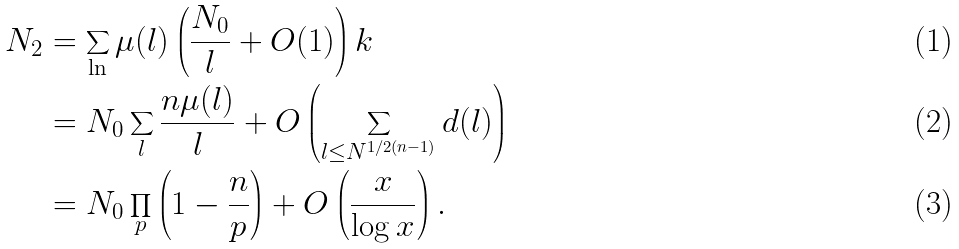<formula> <loc_0><loc_0><loc_500><loc_500>N _ { 2 } & = \sum _ { \ln } \mu ( l ) \left ( \frac { N _ { 0 } } { l } + O ( 1 ) \right ) k \\ & = N _ { 0 } \sum _ { l } \frac { n \mu ( l ) } { l } + O \left ( \sum _ { l \leq N ^ { 1 / 2 ( n - 1 ) } } d ( l ) \right ) \\ & = N _ { 0 } \prod _ { p } \left ( 1 - \frac { n } { p } \right ) + O \left ( \frac { x } { \log x } \right ) .</formula> 